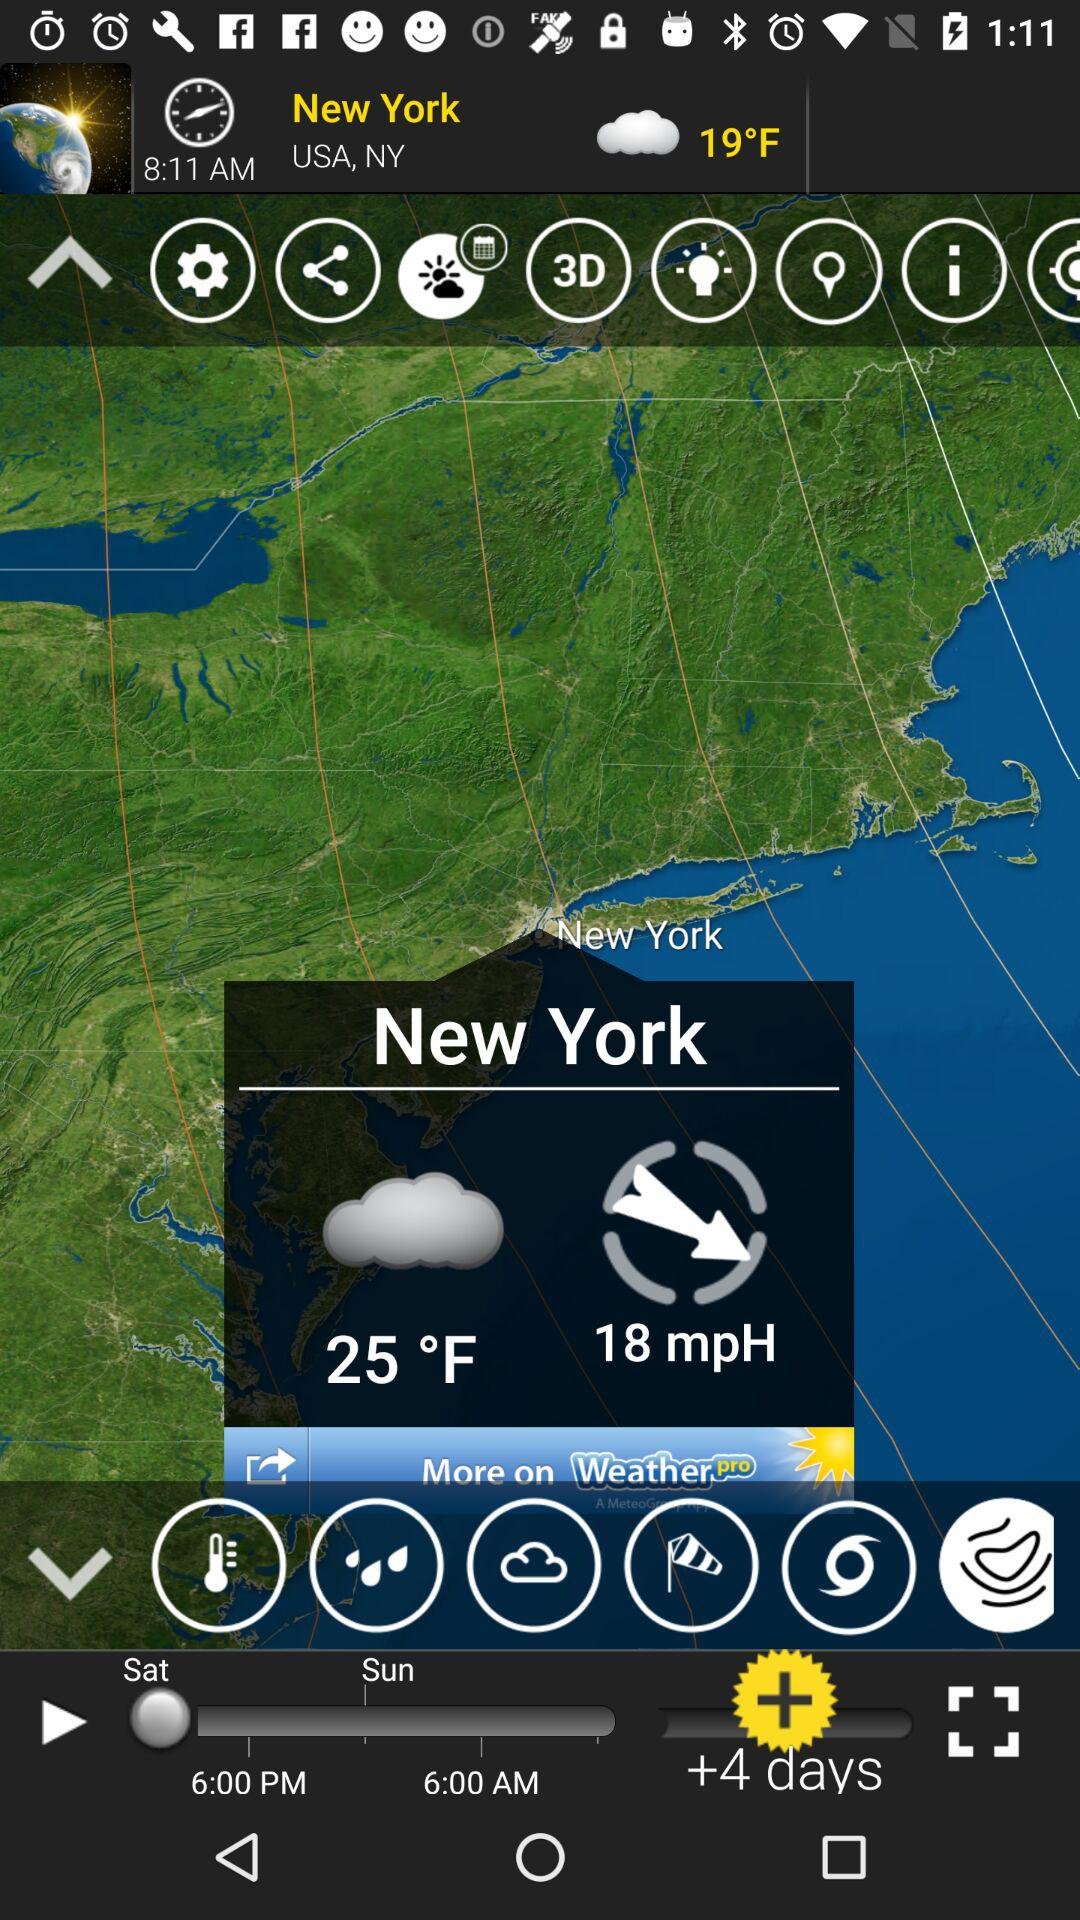At how many mph is the wind blowing? The wind is blowing at 18 mph. 